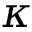Convert formula to latex. <formula><loc_0><loc_0><loc_500><loc_500>\kappa</formula> 